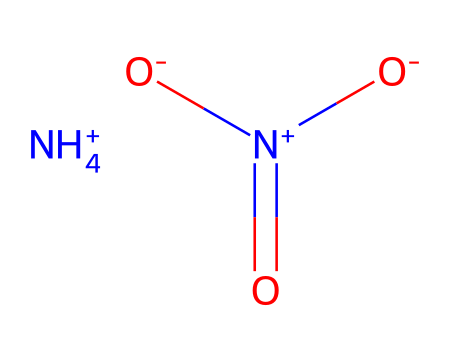What is the total number of nitrogen atoms in the structure? In the given SMILES representation, there are two nitrogen atoms indicated: one in the ammonium ion (NH4+) and one in the nitrate ion (N+). Therefore, counting these yields a total of two nitrogen atoms.
Answer: two How many oxygen atoms are present in the structure? The SMILES shows that the nitrate ion has three oxygen atoms (as indicated by [O-][O-] and [O-], while the ammonium ion has no oxygen atoms; thus, the total number of oxygen atoms is three.
Answer: three What is the charge of the ammonium ion in this structure? The ammonium ion is represented by [NH4+], which indicates it has a positive charge (+). Therefore, the charge of the ammonium ion in this structure is one positive.
Answer: one positive Is ammonium nitrate considered an oxidizer? Ammonium nitrate is classified as an oxidizer due to its ability to release oxygen when decomposed, which supports the combustion of other materials in its presence.
Answer: yes What type of bond connects the nitrogen and oxygen in the nitrate ion? The nitrogen in the nitrate ion forms a double bond with one oxygen and single bonds with the other two, characterized by the notation "(=O)" for the double bond.
Answer: double bond How does the arrangement of atoms in ammonium nitrate allow it to serve as a cold pack? The molecular arrangement and the endothermic dissolution of ammonium nitrate in water lead to a decrease in temperature, allowing it to effectively serve as a cold pack when dissolved, providing cooling relief in first aid.
Answer: endothermic dissolution 